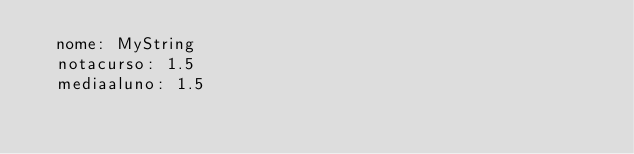Convert code to text. <code><loc_0><loc_0><loc_500><loc_500><_YAML_>  nome: MyString
  notacurso: 1.5
  mediaaluno: 1.5
</code> 